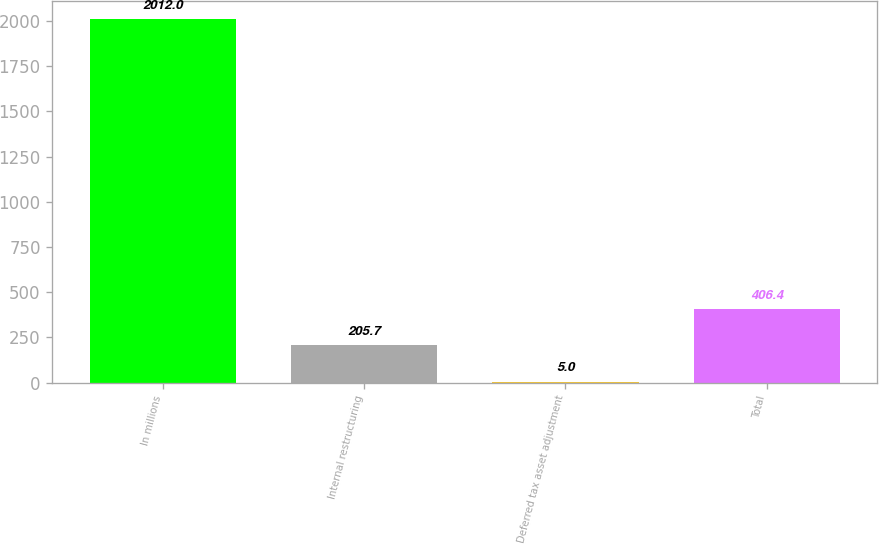Convert chart to OTSL. <chart><loc_0><loc_0><loc_500><loc_500><bar_chart><fcel>In millions<fcel>Internal restructuring<fcel>Deferred tax asset adjustment<fcel>Total<nl><fcel>2012<fcel>205.7<fcel>5<fcel>406.4<nl></chart> 